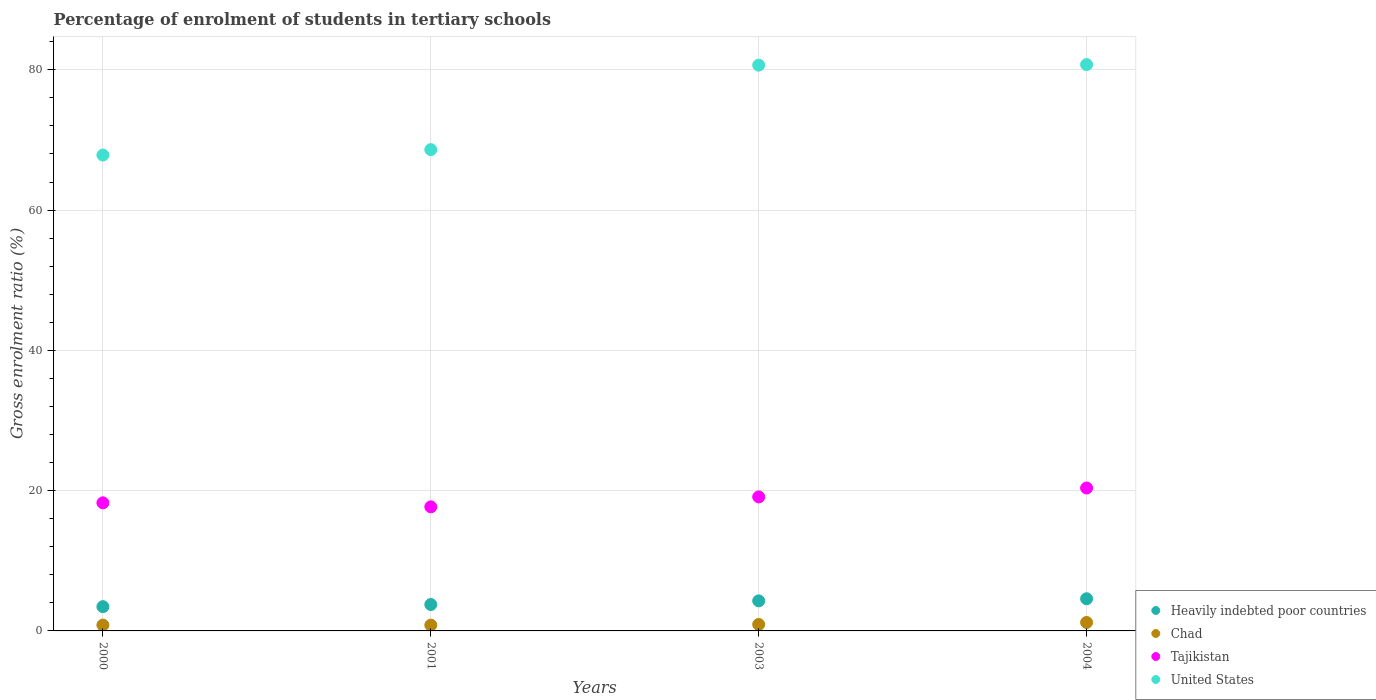Is the number of dotlines equal to the number of legend labels?
Provide a short and direct response. Yes. What is the percentage of students enrolled in tertiary schools in United States in 2001?
Give a very brief answer. 68.62. Across all years, what is the maximum percentage of students enrolled in tertiary schools in Heavily indebted poor countries?
Keep it short and to the point. 4.58. Across all years, what is the minimum percentage of students enrolled in tertiary schools in Heavily indebted poor countries?
Ensure brevity in your answer.  3.46. In which year was the percentage of students enrolled in tertiary schools in Tajikistan maximum?
Ensure brevity in your answer.  2004. What is the total percentage of students enrolled in tertiary schools in Chad in the graph?
Offer a very short reply. 3.78. What is the difference between the percentage of students enrolled in tertiary schools in Tajikistan in 2001 and that in 2004?
Provide a short and direct response. -2.69. What is the difference between the percentage of students enrolled in tertiary schools in Chad in 2003 and the percentage of students enrolled in tertiary schools in Heavily indebted poor countries in 2001?
Keep it short and to the point. -2.84. What is the average percentage of students enrolled in tertiary schools in United States per year?
Your response must be concise. 74.47. In the year 2003, what is the difference between the percentage of students enrolled in tertiary schools in Chad and percentage of students enrolled in tertiary schools in Tajikistan?
Make the answer very short. -18.19. What is the ratio of the percentage of students enrolled in tertiary schools in Heavily indebted poor countries in 2000 to that in 2004?
Your answer should be compact. 0.75. Is the difference between the percentage of students enrolled in tertiary schools in Chad in 2000 and 2001 greater than the difference between the percentage of students enrolled in tertiary schools in Tajikistan in 2000 and 2001?
Your answer should be very brief. No. What is the difference between the highest and the second highest percentage of students enrolled in tertiary schools in United States?
Ensure brevity in your answer.  0.08. What is the difference between the highest and the lowest percentage of students enrolled in tertiary schools in Chad?
Offer a terse response. 0.38. Is it the case that in every year, the sum of the percentage of students enrolled in tertiary schools in Chad and percentage of students enrolled in tertiary schools in Heavily indebted poor countries  is greater than the sum of percentage of students enrolled in tertiary schools in Tajikistan and percentage of students enrolled in tertiary schools in United States?
Your answer should be compact. No. Is it the case that in every year, the sum of the percentage of students enrolled in tertiary schools in Tajikistan and percentage of students enrolled in tertiary schools in Heavily indebted poor countries  is greater than the percentage of students enrolled in tertiary schools in United States?
Provide a succinct answer. No. Does the percentage of students enrolled in tertiary schools in Heavily indebted poor countries monotonically increase over the years?
Offer a very short reply. Yes. How many years are there in the graph?
Ensure brevity in your answer.  4. Are the values on the major ticks of Y-axis written in scientific E-notation?
Ensure brevity in your answer.  No. Does the graph contain grids?
Provide a short and direct response. Yes. Where does the legend appear in the graph?
Offer a very short reply. Bottom right. How are the legend labels stacked?
Your answer should be very brief. Vertical. What is the title of the graph?
Give a very brief answer. Percentage of enrolment of students in tertiary schools. What is the label or title of the X-axis?
Your response must be concise. Years. What is the label or title of the Y-axis?
Keep it short and to the point. Gross enrolment ratio (%). What is the Gross enrolment ratio (%) of Heavily indebted poor countries in 2000?
Ensure brevity in your answer.  3.46. What is the Gross enrolment ratio (%) of Chad in 2000?
Your answer should be very brief. 0.83. What is the Gross enrolment ratio (%) in Tajikistan in 2000?
Give a very brief answer. 18.26. What is the Gross enrolment ratio (%) of United States in 2000?
Your response must be concise. 67.85. What is the Gross enrolment ratio (%) in Heavily indebted poor countries in 2001?
Offer a very short reply. 3.76. What is the Gross enrolment ratio (%) in Chad in 2001?
Your answer should be very brief. 0.83. What is the Gross enrolment ratio (%) of Tajikistan in 2001?
Your answer should be very brief. 17.69. What is the Gross enrolment ratio (%) of United States in 2001?
Ensure brevity in your answer.  68.62. What is the Gross enrolment ratio (%) in Heavily indebted poor countries in 2003?
Provide a succinct answer. 4.29. What is the Gross enrolment ratio (%) of Chad in 2003?
Provide a short and direct response. 0.92. What is the Gross enrolment ratio (%) in Tajikistan in 2003?
Offer a very short reply. 19.11. What is the Gross enrolment ratio (%) of United States in 2003?
Offer a terse response. 80.66. What is the Gross enrolment ratio (%) of Heavily indebted poor countries in 2004?
Provide a succinct answer. 4.58. What is the Gross enrolment ratio (%) of Chad in 2004?
Provide a succinct answer. 1.21. What is the Gross enrolment ratio (%) in Tajikistan in 2004?
Your answer should be very brief. 20.38. What is the Gross enrolment ratio (%) of United States in 2004?
Your answer should be compact. 80.74. Across all years, what is the maximum Gross enrolment ratio (%) in Heavily indebted poor countries?
Your answer should be compact. 4.58. Across all years, what is the maximum Gross enrolment ratio (%) of Chad?
Ensure brevity in your answer.  1.21. Across all years, what is the maximum Gross enrolment ratio (%) of Tajikistan?
Ensure brevity in your answer.  20.38. Across all years, what is the maximum Gross enrolment ratio (%) in United States?
Keep it short and to the point. 80.74. Across all years, what is the minimum Gross enrolment ratio (%) in Heavily indebted poor countries?
Offer a terse response. 3.46. Across all years, what is the minimum Gross enrolment ratio (%) in Chad?
Provide a succinct answer. 0.83. Across all years, what is the minimum Gross enrolment ratio (%) in Tajikistan?
Provide a short and direct response. 17.69. Across all years, what is the minimum Gross enrolment ratio (%) in United States?
Ensure brevity in your answer.  67.85. What is the total Gross enrolment ratio (%) in Heavily indebted poor countries in the graph?
Provide a short and direct response. 16.1. What is the total Gross enrolment ratio (%) in Chad in the graph?
Offer a very short reply. 3.78. What is the total Gross enrolment ratio (%) of Tajikistan in the graph?
Offer a very short reply. 75.44. What is the total Gross enrolment ratio (%) of United States in the graph?
Provide a short and direct response. 297.87. What is the difference between the Gross enrolment ratio (%) of Heavily indebted poor countries in 2000 and that in 2001?
Provide a succinct answer. -0.3. What is the difference between the Gross enrolment ratio (%) in Chad in 2000 and that in 2001?
Your response must be concise. 0.01. What is the difference between the Gross enrolment ratio (%) in Tajikistan in 2000 and that in 2001?
Keep it short and to the point. 0.57. What is the difference between the Gross enrolment ratio (%) of United States in 2000 and that in 2001?
Provide a succinct answer. -0.77. What is the difference between the Gross enrolment ratio (%) in Heavily indebted poor countries in 2000 and that in 2003?
Your response must be concise. -0.83. What is the difference between the Gross enrolment ratio (%) in Chad in 2000 and that in 2003?
Give a very brief answer. -0.09. What is the difference between the Gross enrolment ratio (%) in Tajikistan in 2000 and that in 2003?
Your response must be concise. -0.84. What is the difference between the Gross enrolment ratio (%) in United States in 2000 and that in 2003?
Make the answer very short. -12.81. What is the difference between the Gross enrolment ratio (%) of Heavily indebted poor countries in 2000 and that in 2004?
Your answer should be very brief. -1.12. What is the difference between the Gross enrolment ratio (%) of Chad in 2000 and that in 2004?
Your answer should be very brief. -0.37. What is the difference between the Gross enrolment ratio (%) of Tajikistan in 2000 and that in 2004?
Provide a short and direct response. -2.11. What is the difference between the Gross enrolment ratio (%) in United States in 2000 and that in 2004?
Offer a very short reply. -12.89. What is the difference between the Gross enrolment ratio (%) of Heavily indebted poor countries in 2001 and that in 2003?
Give a very brief answer. -0.52. What is the difference between the Gross enrolment ratio (%) of Chad in 2001 and that in 2003?
Keep it short and to the point. -0.1. What is the difference between the Gross enrolment ratio (%) of Tajikistan in 2001 and that in 2003?
Keep it short and to the point. -1.42. What is the difference between the Gross enrolment ratio (%) of United States in 2001 and that in 2003?
Offer a very short reply. -12.04. What is the difference between the Gross enrolment ratio (%) of Heavily indebted poor countries in 2001 and that in 2004?
Keep it short and to the point. -0.82. What is the difference between the Gross enrolment ratio (%) in Chad in 2001 and that in 2004?
Your answer should be compact. -0.38. What is the difference between the Gross enrolment ratio (%) in Tajikistan in 2001 and that in 2004?
Offer a very short reply. -2.69. What is the difference between the Gross enrolment ratio (%) of United States in 2001 and that in 2004?
Provide a short and direct response. -12.12. What is the difference between the Gross enrolment ratio (%) in Heavily indebted poor countries in 2003 and that in 2004?
Offer a terse response. -0.3. What is the difference between the Gross enrolment ratio (%) of Chad in 2003 and that in 2004?
Give a very brief answer. -0.28. What is the difference between the Gross enrolment ratio (%) of Tajikistan in 2003 and that in 2004?
Keep it short and to the point. -1.27. What is the difference between the Gross enrolment ratio (%) of United States in 2003 and that in 2004?
Offer a terse response. -0.08. What is the difference between the Gross enrolment ratio (%) in Heavily indebted poor countries in 2000 and the Gross enrolment ratio (%) in Chad in 2001?
Make the answer very short. 2.63. What is the difference between the Gross enrolment ratio (%) in Heavily indebted poor countries in 2000 and the Gross enrolment ratio (%) in Tajikistan in 2001?
Provide a short and direct response. -14.23. What is the difference between the Gross enrolment ratio (%) of Heavily indebted poor countries in 2000 and the Gross enrolment ratio (%) of United States in 2001?
Offer a very short reply. -65.16. What is the difference between the Gross enrolment ratio (%) of Chad in 2000 and the Gross enrolment ratio (%) of Tajikistan in 2001?
Ensure brevity in your answer.  -16.86. What is the difference between the Gross enrolment ratio (%) of Chad in 2000 and the Gross enrolment ratio (%) of United States in 2001?
Your answer should be compact. -67.79. What is the difference between the Gross enrolment ratio (%) of Tajikistan in 2000 and the Gross enrolment ratio (%) of United States in 2001?
Ensure brevity in your answer.  -50.35. What is the difference between the Gross enrolment ratio (%) of Heavily indebted poor countries in 2000 and the Gross enrolment ratio (%) of Chad in 2003?
Make the answer very short. 2.54. What is the difference between the Gross enrolment ratio (%) in Heavily indebted poor countries in 2000 and the Gross enrolment ratio (%) in Tajikistan in 2003?
Offer a terse response. -15.65. What is the difference between the Gross enrolment ratio (%) of Heavily indebted poor countries in 2000 and the Gross enrolment ratio (%) of United States in 2003?
Your answer should be very brief. -77.2. What is the difference between the Gross enrolment ratio (%) in Chad in 2000 and the Gross enrolment ratio (%) in Tajikistan in 2003?
Ensure brevity in your answer.  -18.28. What is the difference between the Gross enrolment ratio (%) of Chad in 2000 and the Gross enrolment ratio (%) of United States in 2003?
Keep it short and to the point. -79.83. What is the difference between the Gross enrolment ratio (%) in Tajikistan in 2000 and the Gross enrolment ratio (%) in United States in 2003?
Offer a very short reply. -62.4. What is the difference between the Gross enrolment ratio (%) of Heavily indebted poor countries in 2000 and the Gross enrolment ratio (%) of Chad in 2004?
Give a very brief answer. 2.25. What is the difference between the Gross enrolment ratio (%) of Heavily indebted poor countries in 2000 and the Gross enrolment ratio (%) of Tajikistan in 2004?
Keep it short and to the point. -16.92. What is the difference between the Gross enrolment ratio (%) in Heavily indebted poor countries in 2000 and the Gross enrolment ratio (%) in United States in 2004?
Your response must be concise. -77.28. What is the difference between the Gross enrolment ratio (%) in Chad in 2000 and the Gross enrolment ratio (%) in Tajikistan in 2004?
Offer a terse response. -19.54. What is the difference between the Gross enrolment ratio (%) in Chad in 2000 and the Gross enrolment ratio (%) in United States in 2004?
Your answer should be compact. -79.91. What is the difference between the Gross enrolment ratio (%) in Tajikistan in 2000 and the Gross enrolment ratio (%) in United States in 2004?
Give a very brief answer. -62.48. What is the difference between the Gross enrolment ratio (%) in Heavily indebted poor countries in 2001 and the Gross enrolment ratio (%) in Chad in 2003?
Offer a very short reply. 2.84. What is the difference between the Gross enrolment ratio (%) of Heavily indebted poor countries in 2001 and the Gross enrolment ratio (%) of Tajikistan in 2003?
Offer a very short reply. -15.34. What is the difference between the Gross enrolment ratio (%) of Heavily indebted poor countries in 2001 and the Gross enrolment ratio (%) of United States in 2003?
Provide a succinct answer. -76.9. What is the difference between the Gross enrolment ratio (%) in Chad in 2001 and the Gross enrolment ratio (%) in Tajikistan in 2003?
Provide a succinct answer. -18.28. What is the difference between the Gross enrolment ratio (%) in Chad in 2001 and the Gross enrolment ratio (%) in United States in 2003?
Your response must be concise. -79.84. What is the difference between the Gross enrolment ratio (%) of Tajikistan in 2001 and the Gross enrolment ratio (%) of United States in 2003?
Offer a very short reply. -62.97. What is the difference between the Gross enrolment ratio (%) of Heavily indebted poor countries in 2001 and the Gross enrolment ratio (%) of Chad in 2004?
Your answer should be very brief. 2.56. What is the difference between the Gross enrolment ratio (%) of Heavily indebted poor countries in 2001 and the Gross enrolment ratio (%) of Tajikistan in 2004?
Offer a terse response. -16.61. What is the difference between the Gross enrolment ratio (%) of Heavily indebted poor countries in 2001 and the Gross enrolment ratio (%) of United States in 2004?
Make the answer very short. -76.98. What is the difference between the Gross enrolment ratio (%) of Chad in 2001 and the Gross enrolment ratio (%) of Tajikistan in 2004?
Keep it short and to the point. -19.55. What is the difference between the Gross enrolment ratio (%) of Chad in 2001 and the Gross enrolment ratio (%) of United States in 2004?
Make the answer very short. -79.92. What is the difference between the Gross enrolment ratio (%) of Tajikistan in 2001 and the Gross enrolment ratio (%) of United States in 2004?
Ensure brevity in your answer.  -63.05. What is the difference between the Gross enrolment ratio (%) of Heavily indebted poor countries in 2003 and the Gross enrolment ratio (%) of Chad in 2004?
Keep it short and to the point. 3.08. What is the difference between the Gross enrolment ratio (%) in Heavily indebted poor countries in 2003 and the Gross enrolment ratio (%) in Tajikistan in 2004?
Give a very brief answer. -16.09. What is the difference between the Gross enrolment ratio (%) in Heavily indebted poor countries in 2003 and the Gross enrolment ratio (%) in United States in 2004?
Offer a very short reply. -76.46. What is the difference between the Gross enrolment ratio (%) of Chad in 2003 and the Gross enrolment ratio (%) of Tajikistan in 2004?
Your answer should be very brief. -19.45. What is the difference between the Gross enrolment ratio (%) of Chad in 2003 and the Gross enrolment ratio (%) of United States in 2004?
Offer a terse response. -79.82. What is the difference between the Gross enrolment ratio (%) in Tajikistan in 2003 and the Gross enrolment ratio (%) in United States in 2004?
Give a very brief answer. -61.63. What is the average Gross enrolment ratio (%) of Heavily indebted poor countries per year?
Give a very brief answer. 4.02. What is the average Gross enrolment ratio (%) in Chad per year?
Provide a succinct answer. 0.95. What is the average Gross enrolment ratio (%) in Tajikistan per year?
Your answer should be very brief. 18.86. What is the average Gross enrolment ratio (%) of United States per year?
Offer a very short reply. 74.47. In the year 2000, what is the difference between the Gross enrolment ratio (%) in Heavily indebted poor countries and Gross enrolment ratio (%) in Chad?
Provide a succinct answer. 2.63. In the year 2000, what is the difference between the Gross enrolment ratio (%) in Heavily indebted poor countries and Gross enrolment ratio (%) in Tajikistan?
Your answer should be compact. -14.8. In the year 2000, what is the difference between the Gross enrolment ratio (%) of Heavily indebted poor countries and Gross enrolment ratio (%) of United States?
Your answer should be very brief. -64.39. In the year 2000, what is the difference between the Gross enrolment ratio (%) of Chad and Gross enrolment ratio (%) of Tajikistan?
Make the answer very short. -17.43. In the year 2000, what is the difference between the Gross enrolment ratio (%) in Chad and Gross enrolment ratio (%) in United States?
Ensure brevity in your answer.  -67.02. In the year 2000, what is the difference between the Gross enrolment ratio (%) of Tajikistan and Gross enrolment ratio (%) of United States?
Keep it short and to the point. -49.59. In the year 2001, what is the difference between the Gross enrolment ratio (%) in Heavily indebted poor countries and Gross enrolment ratio (%) in Chad?
Offer a very short reply. 2.94. In the year 2001, what is the difference between the Gross enrolment ratio (%) of Heavily indebted poor countries and Gross enrolment ratio (%) of Tajikistan?
Your response must be concise. -13.93. In the year 2001, what is the difference between the Gross enrolment ratio (%) in Heavily indebted poor countries and Gross enrolment ratio (%) in United States?
Offer a very short reply. -64.85. In the year 2001, what is the difference between the Gross enrolment ratio (%) of Chad and Gross enrolment ratio (%) of Tajikistan?
Provide a short and direct response. -16.87. In the year 2001, what is the difference between the Gross enrolment ratio (%) of Chad and Gross enrolment ratio (%) of United States?
Ensure brevity in your answer.  -67.79. In the year 2001, what is the difference between the Gross enrolment ratio (%) of Tajikistan and Gross enrolment ratio (%) of United States?
Ensure brevity in your answer.  -50.93. In the year 2003, what is the difference between the Gross enrolment ratio (%) in Heavily indebted poor countries and Gross enrolment ratio (%) in Chad?
Offer a terse response. 3.36. In the year 2003, what is the difference between the Gross enrolment ratio (%) in Heavily indebted poor countries and Gross enrolment ratio (%) in Tajikistan?
Keep it short and to the point. -14.82. In the year 2003, what is the difference between the Gross enrolment ratio (%) of Heavily indebted poor countries and Gross enrolment ratio (%) of United States?
Your response must be concise. -76.38. In the year 2003, what is the difference between the Gross enrolment ratio (%) in Chad and Gross enrolment ratio (%) in Tajikistan?
Offer a very short reply. -18.19. In the year 2003, what is the difference between the Gross enrolment ratio (%) in Chad and Gross enrolment ratio (%) in United States?
Your answer should be very brief. -79.74. In the year 2003, what is the difference between the Gross enrolment ratio (%) of Tajikistan and Gross enrolment ratio (%) of United States?
Offer a terse response. -61.55. In the year 2004, what is the difference between the Gross enrolment ratio (%) in Heavily indebted poor countries and Gross enrolment ratio (%) in Chad?
Offer a very short reply. 3.38. In the year 2004, what is the difference between the Gross enrolment ratio (%) of Heavily indebted poor countries and Gross enrolment ratio (%) of Tajikistan?
Offer a very short reply. -15.79. In the year 2004, what is the difference between the Gross enrolment ratio (%) in Heavily indebted poor countries and Gross enrolment ratio (%) in United States?
Make the answer very short. -76.16. In the year 2004, what is the difference between the Gross enrolment ratio (%) of Chad and Gross enrolment ratio (%) of Tajikistan?
Provide a short and direct response. -19.17. In the year 2004, what is the difference between the Gross enrolment ratio (%) of Chad and Gross enrolment ratio (%) of United States?
Offer a very short reply. -79.54. In the year 2004, what is the difference between the Gross enrolment ratio (%) in Tajikistan and Gross enrolment ratio (%) in United States?
Provide a short and direct response. -60.37. What is the ratio of the Gross enrolment ratio (%) in Heavily indebted poor countries in 2000 to that in 2001?
Provide a succinct answer. 0.92. What is the ratio of the Gross enrolment ratio (%) in Chad in 2000 to that in 2001?
Ensure brevity in your answer.  1.01. What is the ratio of the Gross enrolment ratio (%) in Tajikistan in 2000 to that in 2001?
Ensure brevity in your answer.  1.03. What is the ratio of the Gross enrolment ratio (%) in United States in 2000 to that in 2001?
Your answer should be very brief. 0.99. What is the ratio of the Gross enrolment ratio (%) in Heavily indebted poor countries in 2000 to that in 2003?
Provide a succinct answer. 0.81. What is the ratio of the Gross enrolment ratio (%) of Chad in 2000 to that in 2003?
Your answer should be very brief. 0.9. What is the ratio of the Gross enrolment ratio (%) in Tajikistan in 2000 to that in 2003?
Your answer should be very brief. 0.96. What is the ratio of the Gross enrolment ratio (%) of United States in 2000 to that in 2003?
Provide a succinct answer. 0.84. What is the ratio of the Gross enrolment ratio (%) in Heavily indebted poor countries in 2000 to that in 2004?
Your answer should be compact. 0.75. What is the ratio of the Gross enrolment ratio (%) in Chad in 2000 to that in 2004?
Offer a terse response. 0.69. What is the ratio of the Gross enrolment ratio (%) of Tajikistan in 2000 to that in 2004?
Provide a succinct answer. 0.9. What is the ratio of the Gross enrolment ratio (%) of United States in 2000 to that in 2004?
Provide a succinct answer. 0.84. What is the ratio of the Gross enrolment ratio (%) in Heavily indebted poor countries in 2001 to that in 2003?
Your answer should be compact. 0.88. What is the ratio of the Gross enrolment ratio (%) of Chad in 2001 to that in 2003?
Ensure brevity in your answer.  0.89. What is the ratio of the Gross enrolment ratio (%) in Tajikistan in 2001 to that in 2003?
Provide a short and direct response. 0.93. What is the ratio of the Gross enrolment ratio (%) of United States in 2001 to that in 2003?
Give a very brief answer. 0.85. What is the ratio of the Gross enrolment ratio (%) in Heavily indebted poor countries in 2001 to that in 2004?
Your response must be concise. 0.82. What is the ratio of the Gross enrolment ratio (%) in Chad in 2001 to that in 2004?
Offer a terse response. 0.68. What is the ratio of the Gross enrolment ratio (%) in Tajikistan in 2001 to that in 2004?
Keep it short and to the point. 0.87. What is the ratio of the Gross enrolment ratio (%) in United States in 2001 to that in 2004?
Ensure brevity in your answer.  0.85. What is the ratio of the Gross enrolment ratio (%) of Heavily indebted poor countries in 2003 to that in 2004?
Keep it short and to the point. 0.93. What is the ratio of the Gross enrolment ratio (%) in Chad in 2003 to that in 2004?
Give a very brief answer. 0.77. What is the ratio of the Gross enrolment ratio (%) in Tajikistan in 2003 to that in 2004?
Ensure brevity in your answer.  0.94. What is the ratio of the Gross enrolment ratio (%) of United States in 2003 to that in 2004?
Offer a very short reply. 1. What is the difference between the highest and the second highest Gross enrolment ratio (%) in Heavily indebted poor countries?
Provide a succinct answer. 0.3. What is the difference between the highest and the second highest Gross enrolment ratio (%) of Chad?
Provide a short and direct response. 0.28. What is the difference between the highest and the second highest Gross enrolment ratio (%) in Tajikistan?
Make the answer very short. 1.27. What is the difference between the highest and the second highest Gross enrolment ratio (%) of United States?
Your response must be concise. 0.08. What is the difference between the highest and the lowest Gross enrolment ratio (%) in Heavily indebted poor countries?
Provide a succinct answer. 1.12. What is the difference between the highest and the lowest Gross enrolment ratio (%) of Chad?
Offer a terse response. 0.38. What is the difference between the highest and the lowest Gross enrolment ratio (%) of Tajikistan?
Your answer should be compact. 2.69. What is the difference between the highest and the lowest Gross enrolment ratio (%) of United States?
Provide a succinct answer. 12.89. 